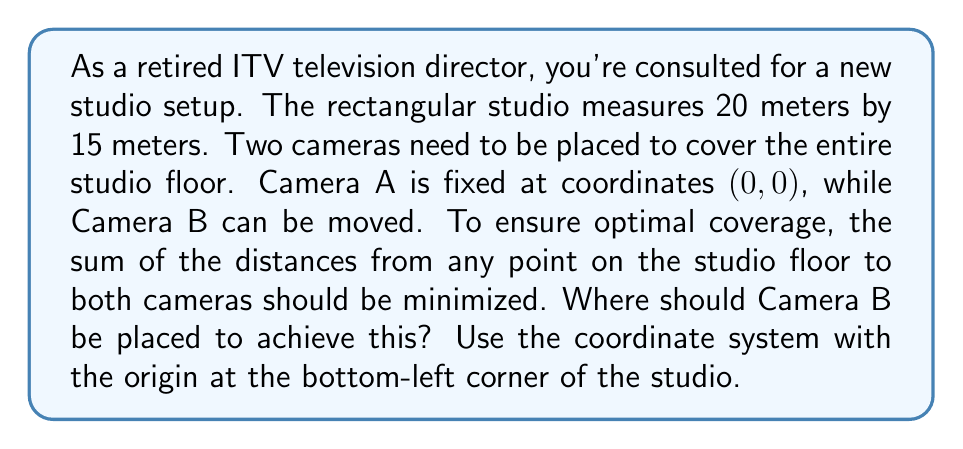Can you solve this math problem? To solve this problem, we need to use the concept of ellipses and their properties. The optimal placement of Camera B will create an ellipse where the sum of distances from any point on the ellipse to the two foci (camera positions) is constant.

1) In an optimal setup, Camera B should be placed at the opposite corner of the studio from Camera A. This means Camera B should be at (20, 15).

2) The center of the ellipse will be at the midpoint between the two cameras:
   $$(\frac{20}{2}, \frac{15}{2}) = (10, 7.5)$$

3) The major axis of the ellipse will be the diagonal of the studio. We can calculate this using the distance formula:
   $$\text{Major axis} = \sqrt{20^2 + 15^2} = 25\text{ meters}$$

4) The distance between the foci (cameras) is also 25 meters.

5) In an ellipse, the sum of the distances from any point to the two foci is equal to the major axis. Therefore, the sum of distances from any point to both cameras will be 25 meters.

6) To verify, let's check a corner point (20, 0):
   Distance to Camera A: $$\sqrt{20^2 + 0^2} = 20$$
   Distance to Camera B: $$\sqrt{0^2 + 15^2} = 15$$
   Sum: 20 + 15 = 35

7) Now check the center (10, 7.5):
   Distance to Camera A: $$\sqrt{10^2 + 7.5^2} = 12.5$$
   Distance to Camera B: $$\sqrt{10^2 + 7.5^2} = 12.5$$
   Sum: 12.5 + 12.5 = 25

This confirms that placing Camera B at (20, 15) provides optimal coverage of the studio floor.

[asy]
unitsize(10);
draw((0,0)--(20,0)--(20,15)--(0,15)--cycle);
dot((0,0),red);
dot((20,15),red);
label("Camera A", (0,0), SW);
label("Camera B", (20,15), NE);
draw((0,0)--(20,15),dashed);
ellipse e=ellipse((10,7.5),(10,0),(0,7.5));
draw(e);
[/asy]
Answer: Camera B should be placed at coordinates (20, 15) to achieve optimal coverage of the studio floor. 